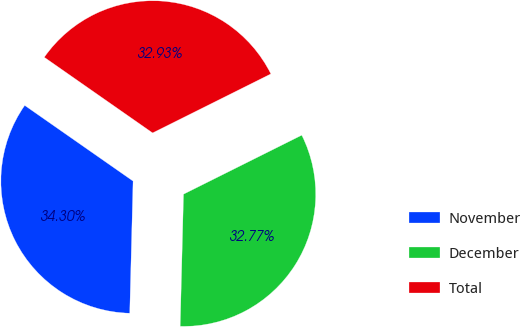<chart> <loc_0><loc_0><loc_500><loc_500><pie_chart><fcel>November<fcel>December<fcel>Total<nl><fcel>34.3%<fcel>32.77%<fcel>32.93%<nl></chart> 